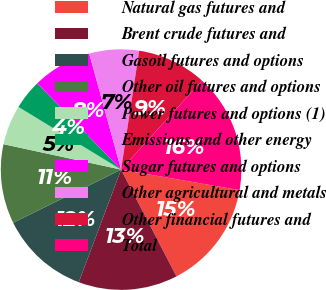Convert chart. <chart><loc_0><loc_0><loc_500><loc_500><pie_chart><fcel>Natural gas futures and<fcel>Brent crude futures and<fcel>Gasoil futures and options<fcel>Other oil futures and options<fcel>Power futures and options (1)<fcel>Emissions and other energy<fcel>Sugar futures and options<fcel>Other agricultural and metals<fcel>Other financial futures and<fcel>Total<nl><fcel>14.66%<fcel>13.33%<fcel>12.0%<fcel>10.67%<fcel>5.34%<fcel>4.01%<fcel>8.0%<fcel>6.67%<fcel>9.33%<fcel>15.99%<nl></chart> 